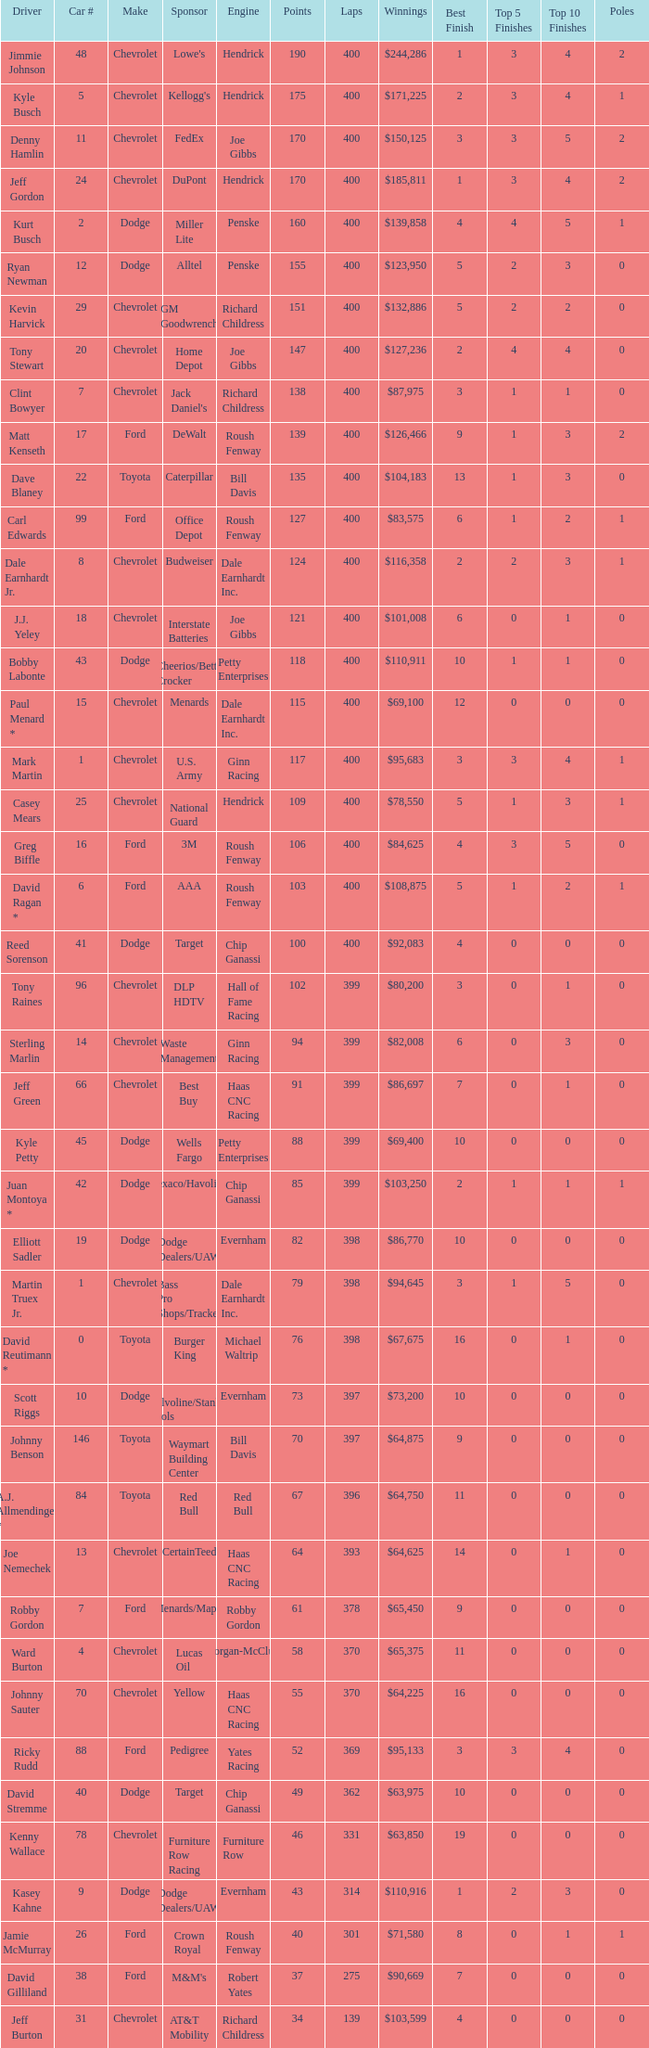What is the make of car 31? Chevrolet. 